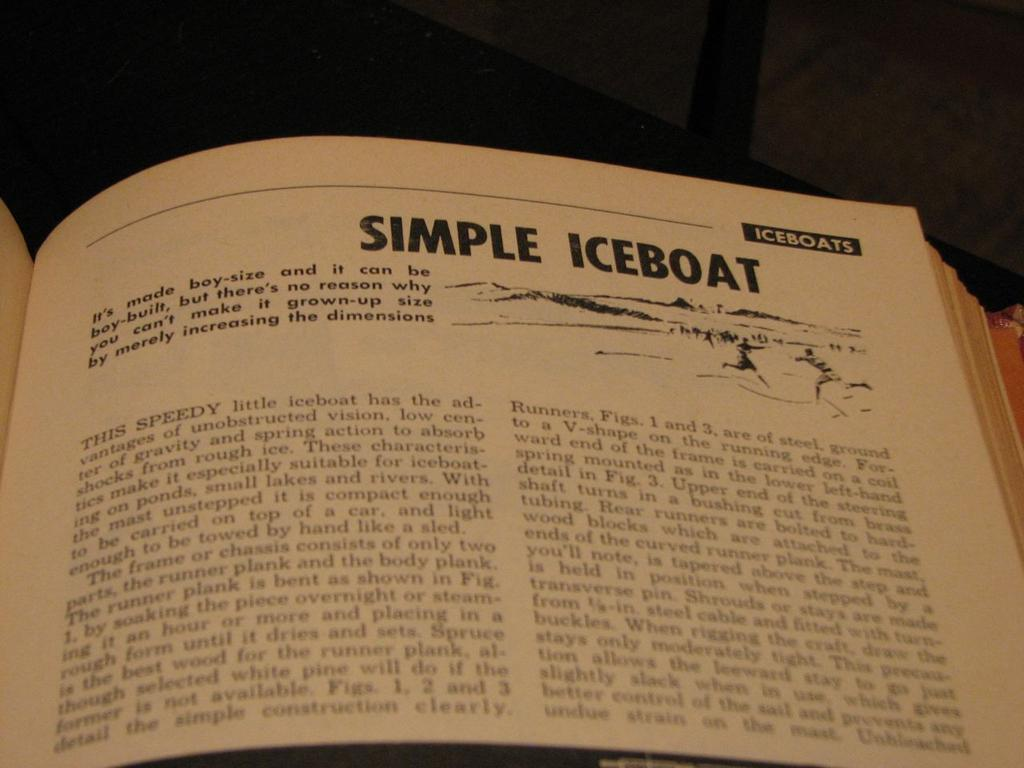<image>
Give a short and clear explanation of the subsequent image. A book is opened to a page that reads Simple Iceboat. 